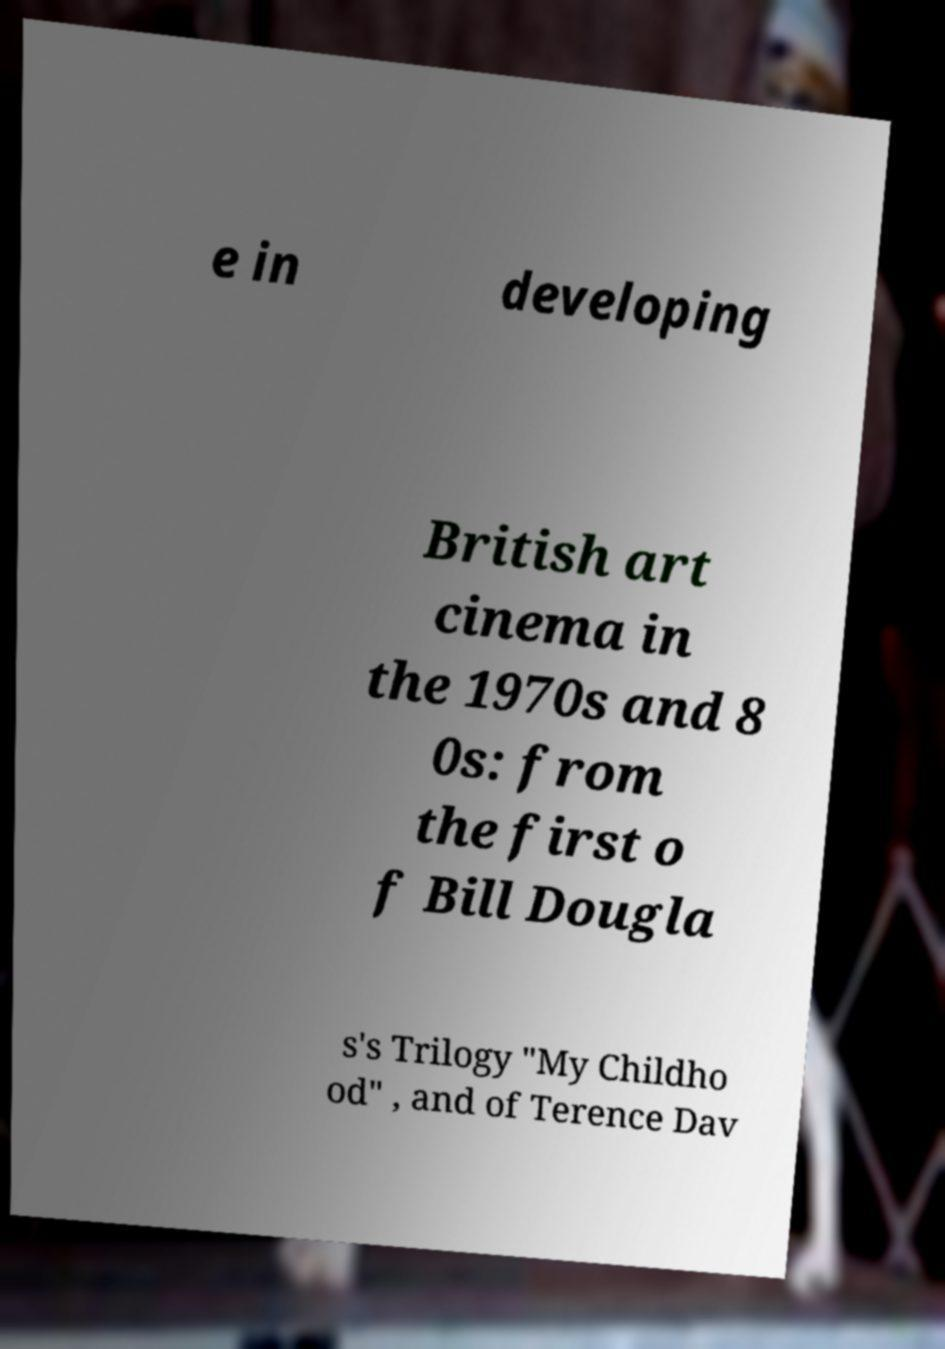There's text embedded in this image that I need extracted. Can you transcribe it verbatim? e in developing British art cinema in the 1970s and 8 0s: from the first o f Bill Dougla s's Trilogy "My Childho od" , and of Terence Dav 